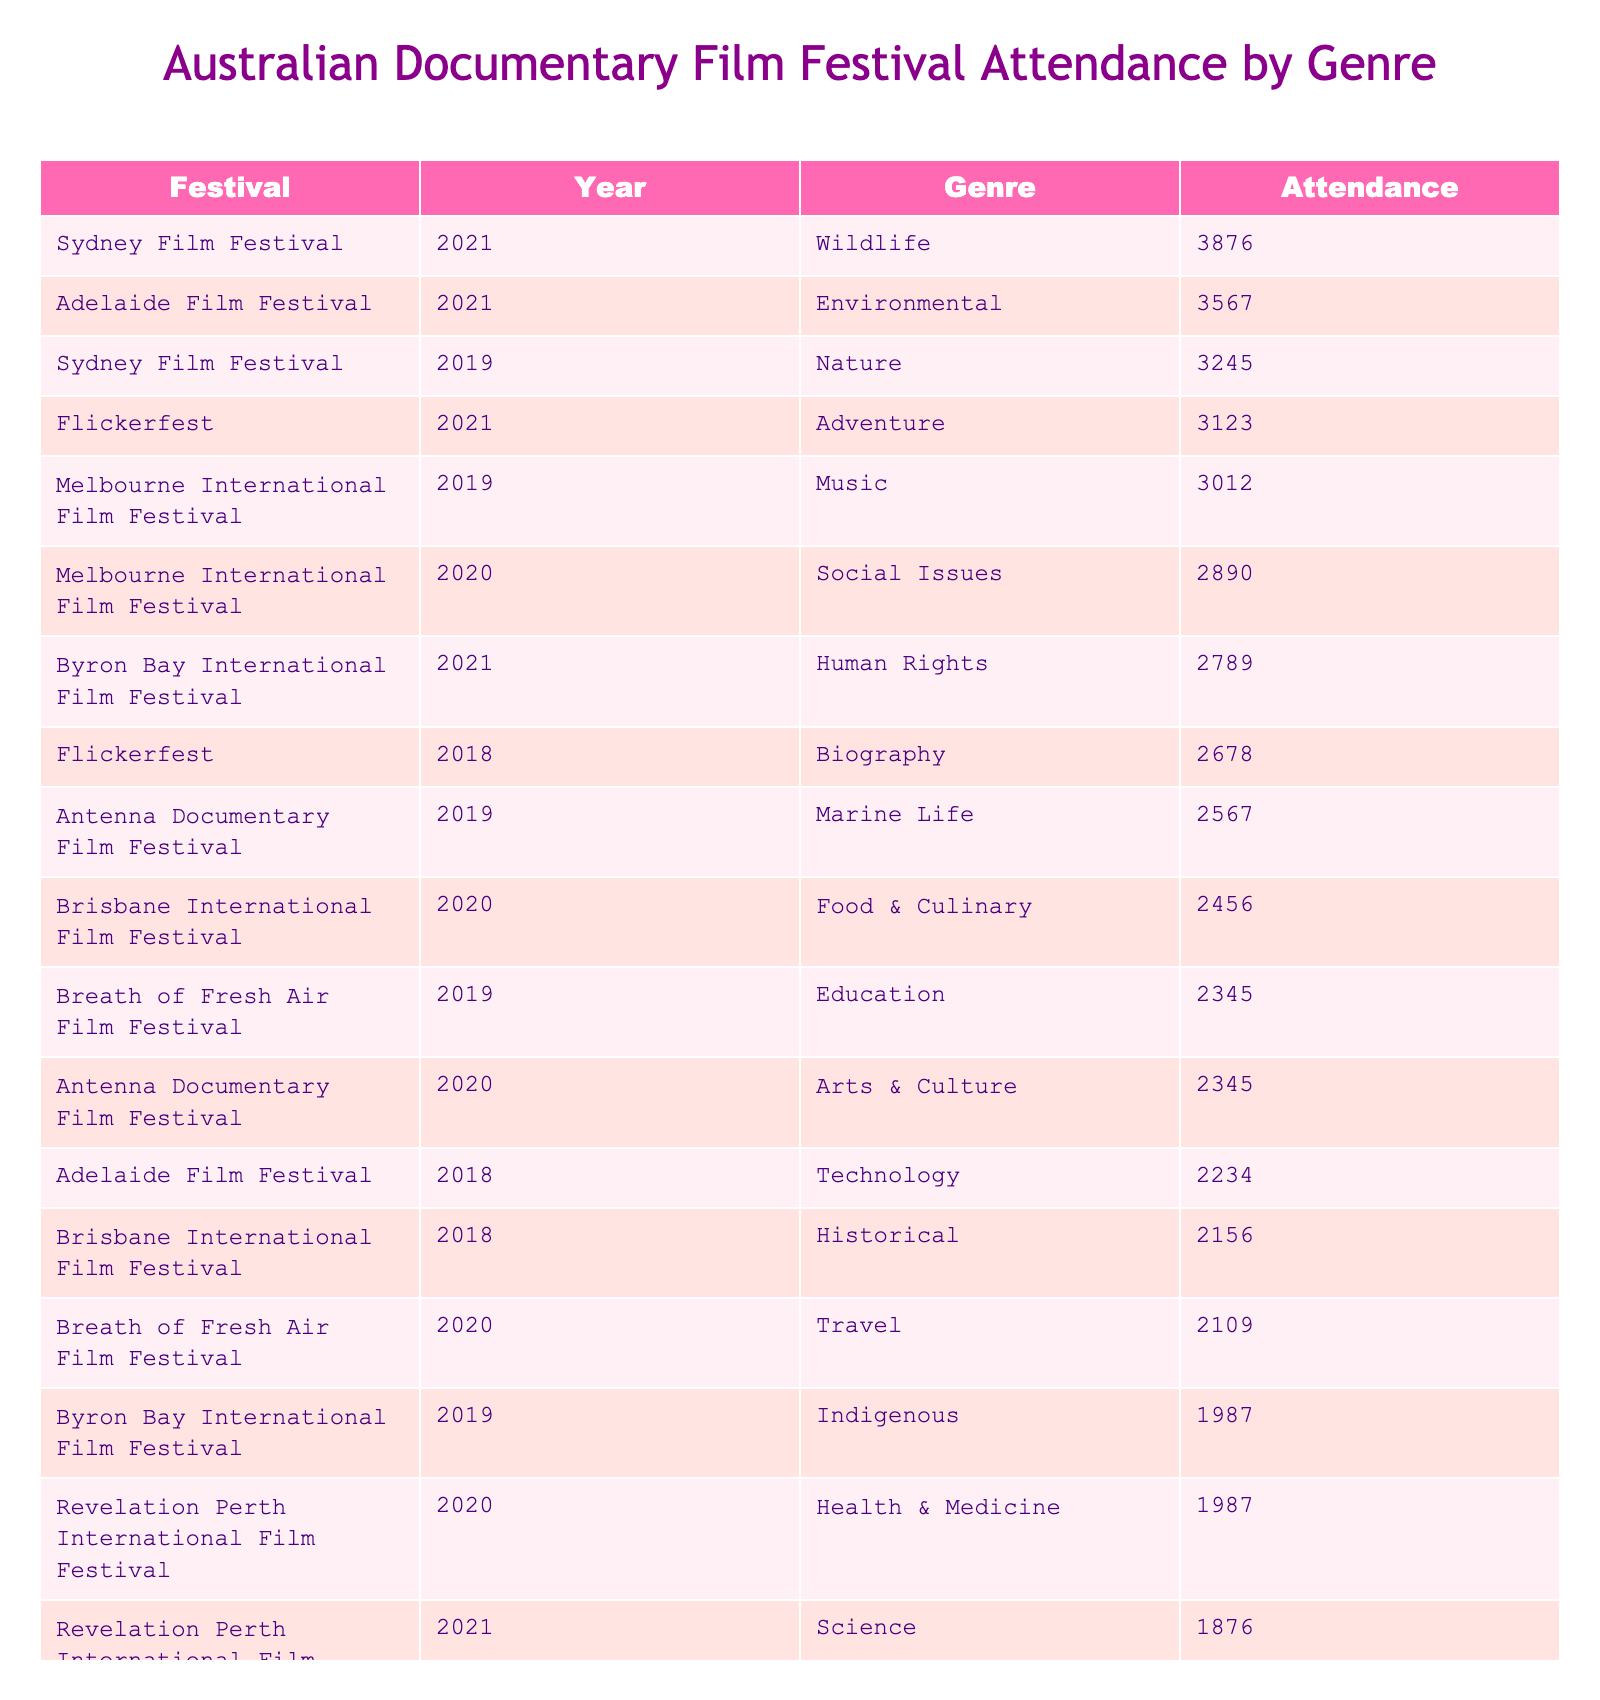What is the highest attendance recorded in the table? The table lists attendance values, with the highest being 3876, which belongs to the Sydney Film Festival in 2021.
Answer: 3876 Which genre had the lowest attendance? Among all the attendance values, the lowest is 1543 for the Sports genre at the Darwin International Film Festival in 2019.
Answer: 1543 What is the total attendance for the Environmental genre? The total attendance for Environmental is the sum of 3567 from the Adelaide Film Festival in 2021.
Answer: 3567 Which festival in 2020 had the highest attendance? By reviewing the 2020 data, the Adelaide Film Festival with 3567 is the highest value among all other festivals from that year.
Answer: 3567 How many genres had attendance greater than 3000? The genres with attendance over 3000 are Nature (3245), Social Issues (2890), Music (3012), Wildlife (3876), and Adventure (3123). There are 4 such genres.
Answer: 4 Is there any festival that recorded the same attendance in different years? No, each attendance value in the table is unique for the combinations of festivals and years listed.
Answer: No What is the average attendance for the Indigenous genre? The attendance for the Indigenous genre is 1987 from the Byron Bay International Film Festival in 2019. Since there's only one record, the average is the same, 1987.
Answer: 1987 Which genre had the highest total attendance across all festivals? By examining the total attendees for each genre and summing them, Wildlife with 3876 holds the highest attendance across all festivals.
Answer: Wildlife How does the attendance for Historical in 2018 compare to the average attendance across all listed genres? The Historical genre had an attendance of 2156, and the average across all genres (total 23758 attendance/15 genres = 1583.87) makes Historical above average.
Answer: Above average Which festival had the second highest attendance in 2021? In 2021, the Sydney Film Festival had the highest attendance of 3876, followed by Byron Bay International Film Festival with 2789, making it the second highest.
Answer: Byron Bay International Film Festival 